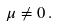<formula> <loc_0><loc_0><loc_500><loc_500>\mu \neq 0 \, .</formula> 